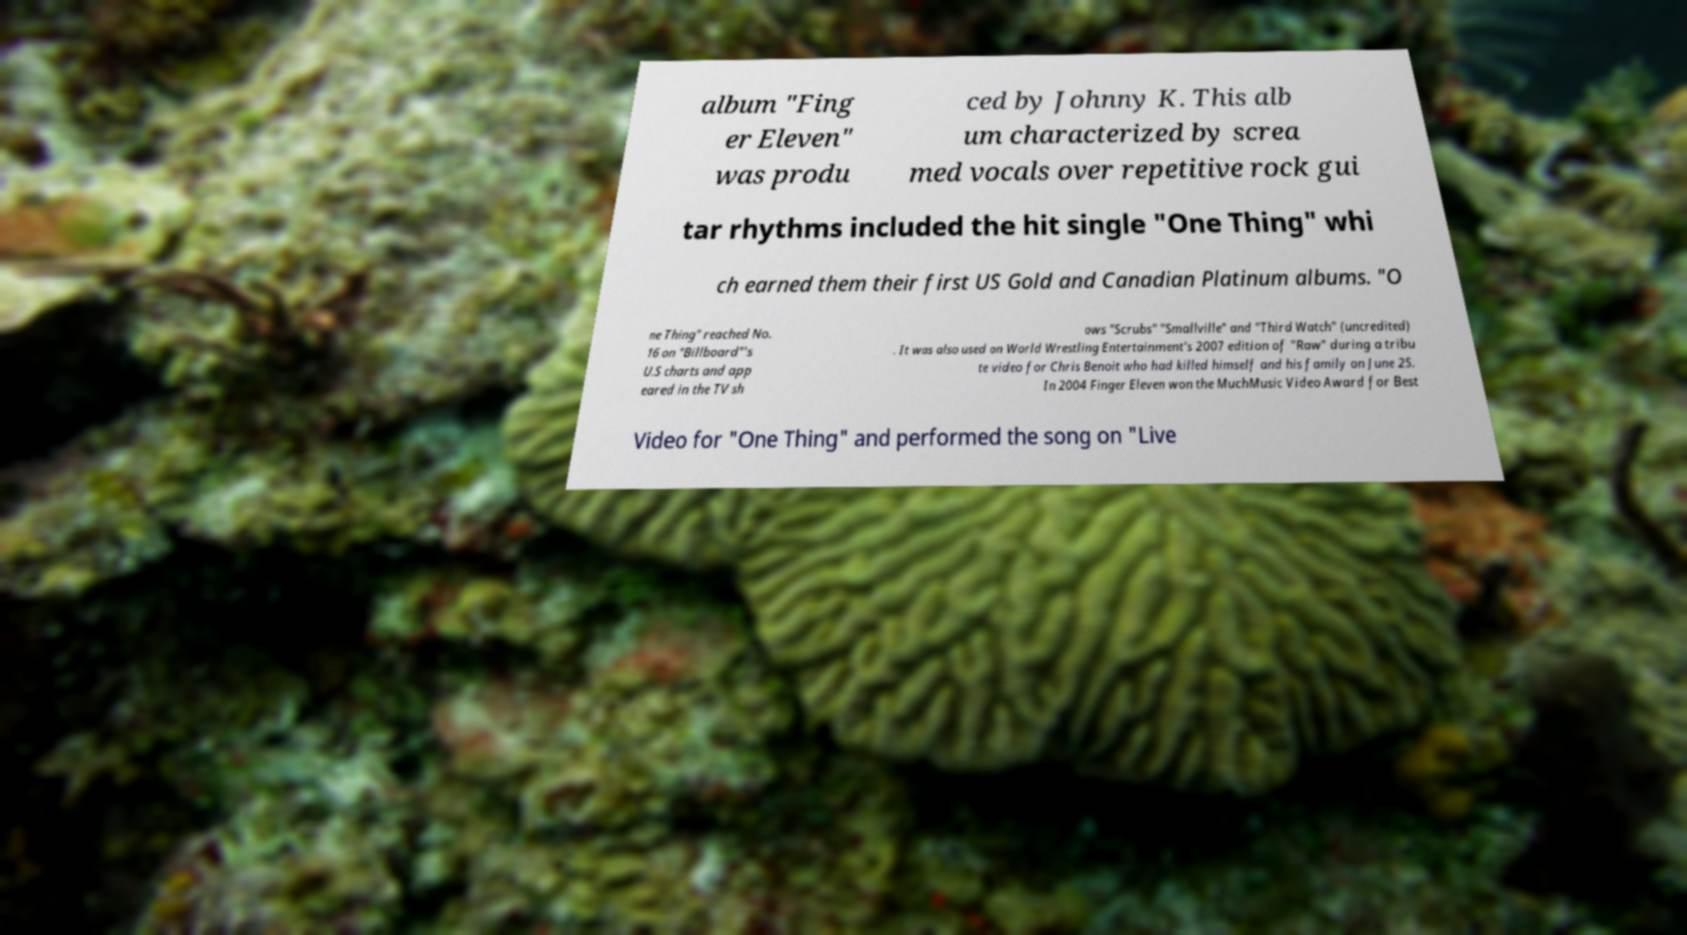Please identify and transcribe the text found in this image. album "Fing er Eleven" was produ ced by Johnny K. This alb um characterized by screa med vocals over repetitive rock gui tar rhythms included the hit single "One Thing" whi ch earned them their first US Gold and Canadian Platinum albums. "O ne Thing" reached No. 16 on "Billboard"'s U.S charts and app eared in the TV sh ows "Scrubs" "Smallville" and "Third Watch" (uncredited) . It was also used on World Wrestling Entertainment's 2007 edition of "Raw" during a tribu te video for Chris Benoit who had killed himself and his family on June 25. In 2004 Finger Eleven won the MuchMusic Video Award for Best Video for "One Thing" and performed the song on "Live 